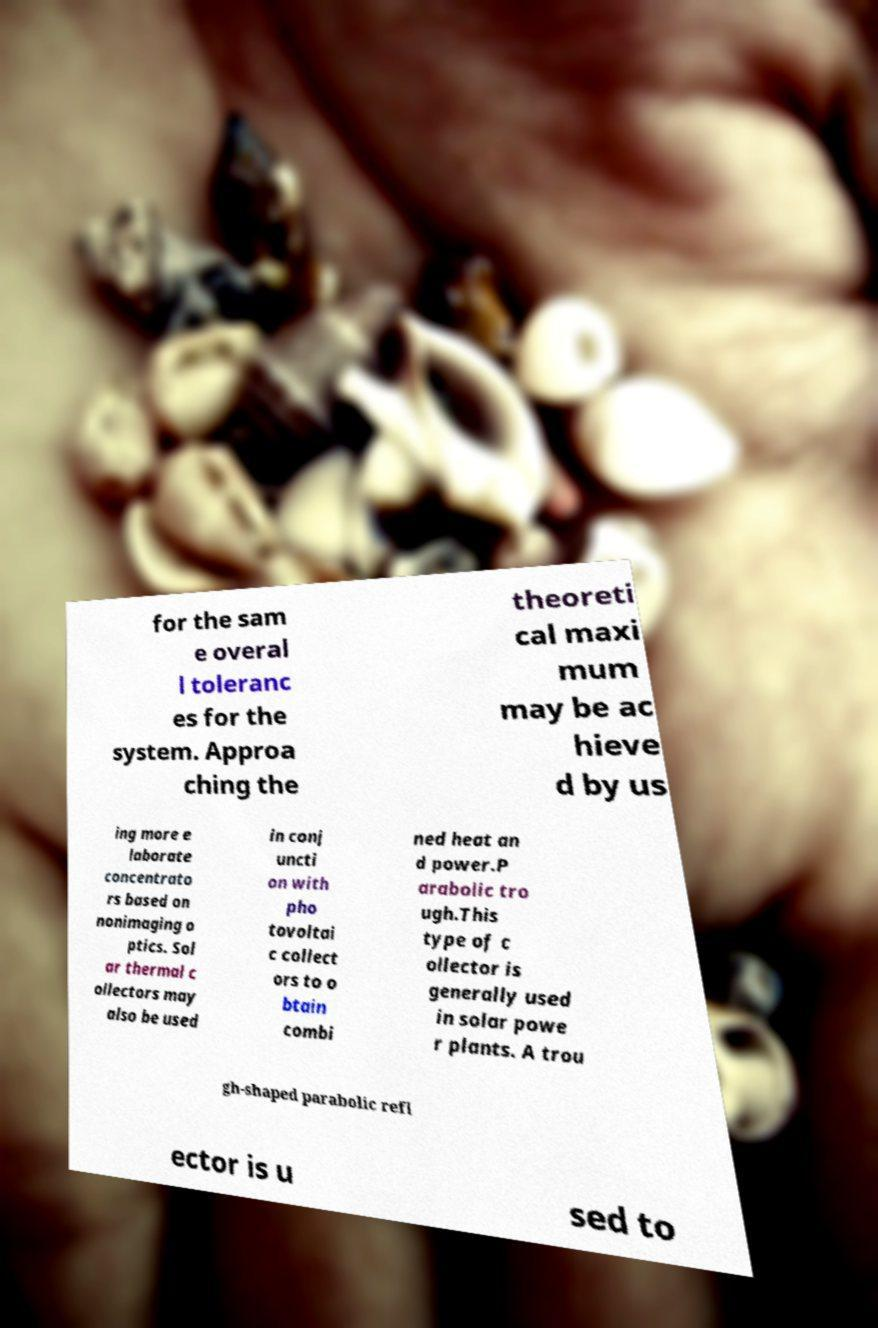Please read and relay the text visible in this image. What does it say? for the sam e overal l toleranc es for the system. Approa ching the theoreti cal maxi mum may be ac hieve d by us ing more e laborate concentrato rs based on nonimaging o ptics. Sol ar thermal c ollectors may also be used in conj uncti on with pho tovoltai c collect ors to o btain combi ned heat an d power.P arabolic tro ugh.This type of c ollector is generally used in solar powe r plants. A trou gh-shaped parabolic refl ector is u sed to 